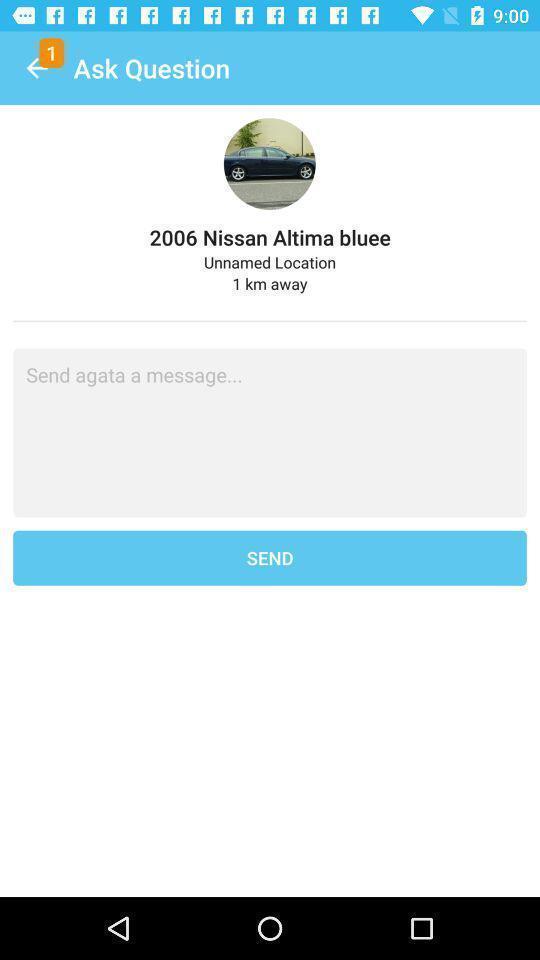What details can you identify in this image? Screen displaying typing message bar. 